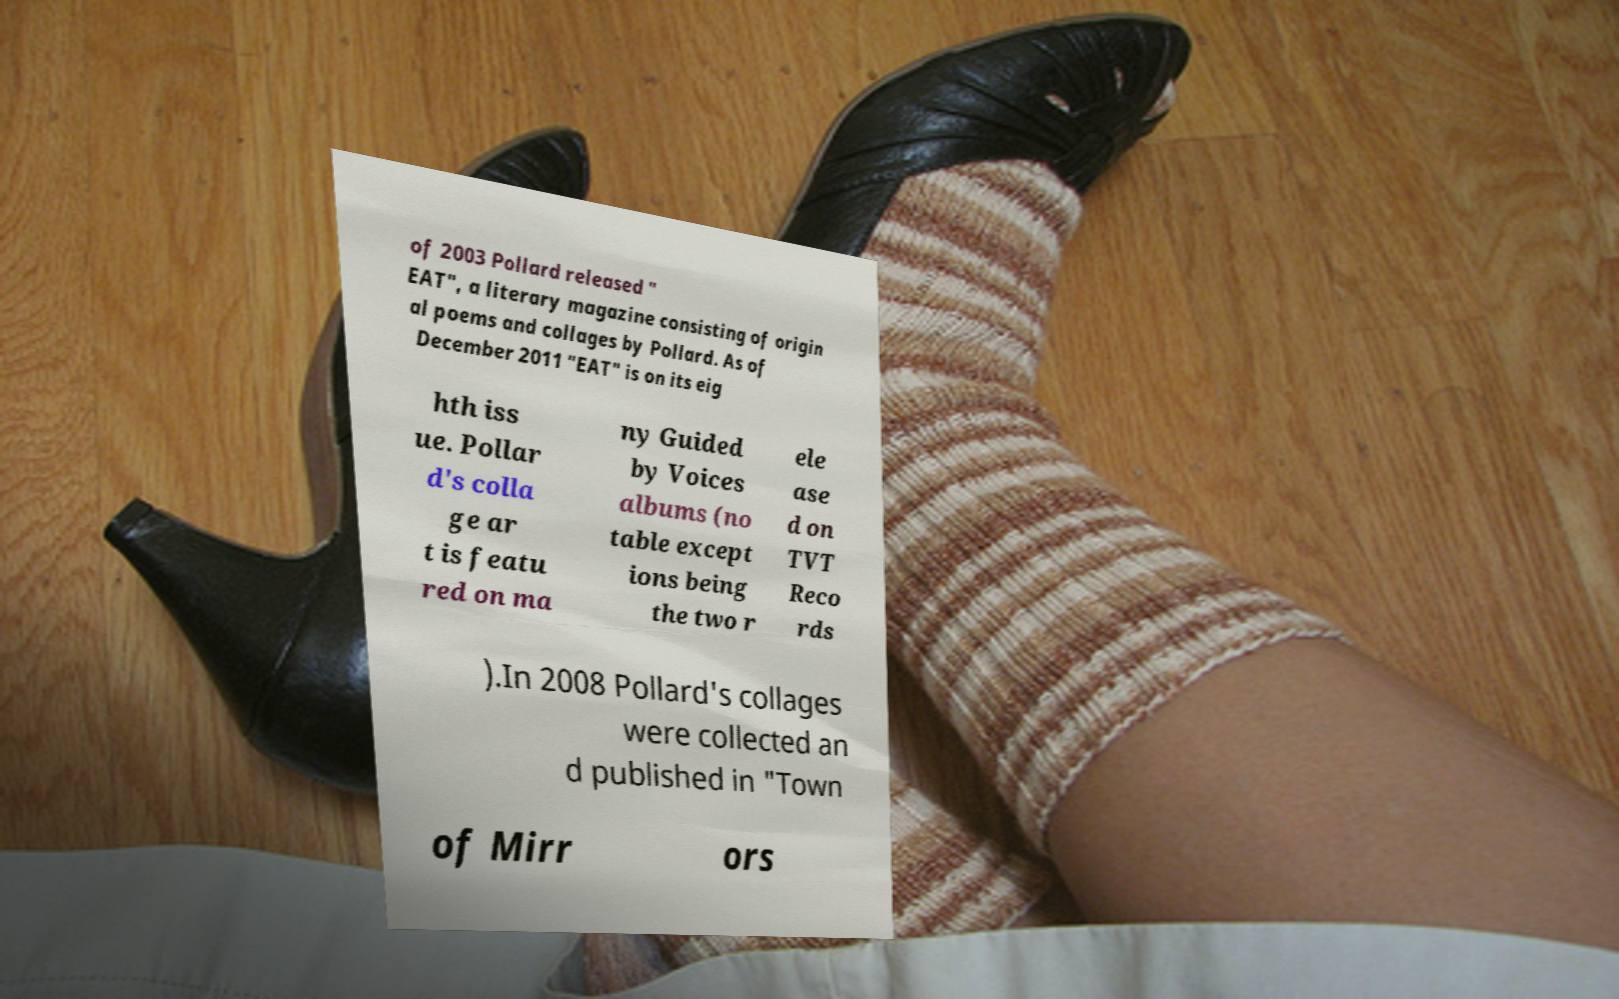I need the written content from this picture converted into text. Can you do that? of 2003 Pollard released " EAT", a literary magazine consisting of origin al poems and collages by Pollard. As of December 2011 "EAT" is on its eig hth iss ue. Pollar d's colla ge ar t is featu red on ma ny Guided by Voices albums (no table except ions being the two r ele ase d on TVT Reco rds ).In 2008 Pollard's collages were collected an d published in "Town of Mirr ors 